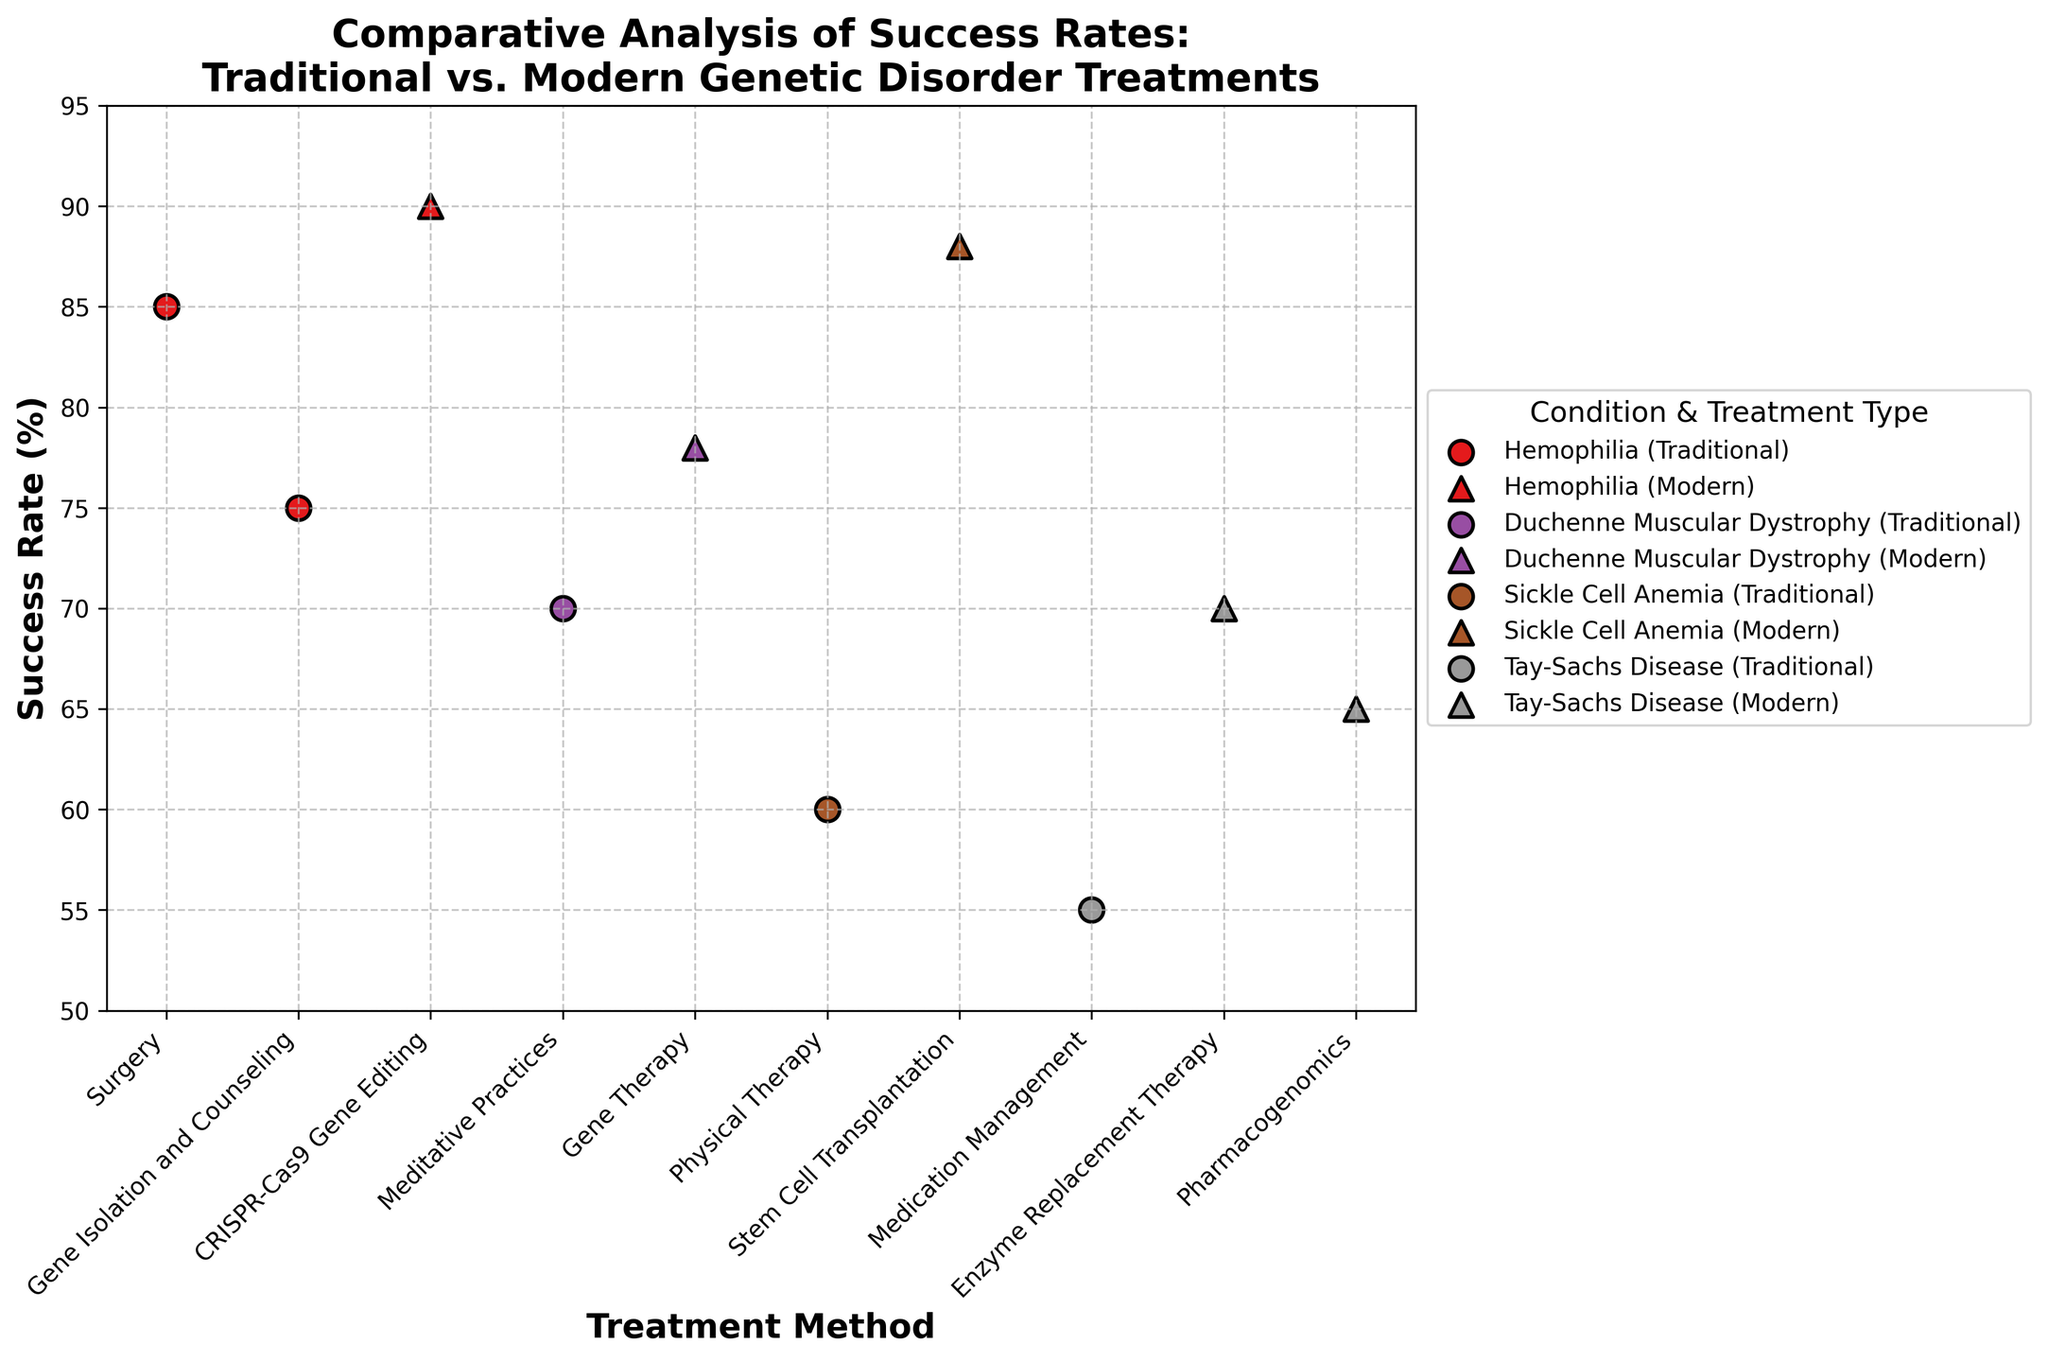Which treatment method has the highest success rate for Tay-Sachs Disease? The treatment methods for Tay-Sachs Disease are "Medication Management," "Enzyme Replacement Therapy," and "Pharmacogenomics." By looking at the success rates, "Enzyme Replacement Therapy" has the highest success rate at 70%.
Answer: Enzyme Replacement Therapy How do the success rates of CRISPR-Cas9 Gene Editing and Surgery compare for Hemophilia? The success rates for these treatments of Hemophilia are: CRISPR-Cas9 Gene Editing (90%) and Surgery (85%). CRISPR-Cas9 Gene Editing has a higher success rate than Surgery.
Answer: CRISPR-Cas9 Gene Editing is higher What is the average success rate for traditional treatments across all conditions? The traditional treatments and their success rates are: Surgery (85%), Meditative Practices (70%), Physical Therapy (60%), Medication Management (55%), and Gene Isolation and Counseling (75%). The average is calculated as: (85 + 70 + 60 + 55 + 75) /5 = 69%.
Answer: 69% Which condition has the largest difference in success rates between traditional and modern treatments? The differences in success rates for each condition are: Hemophilia (90-85=5), Duchenne Muscular Dystrophy (78-70=8), Sickle Cell Anemia (88-60=28), and Tay-Sachs Disease (70-55=15). Sickle Cell Anemia has the largest difference of 28%.
Answer: Sickle Cell Anemia Is there a condition for which traditional treatments have a higher success rate than modern treatments? For all conditions (Hemophilia, Duchenne Muscular Dystrophy, Sickle Cell Anemia, Tay-Sachs Disease), modern treatments have higher or equal success rates compared to traditional treatments.
Answer: No What is the range of success rates for all modern treatments? The success rates for modern treatments are: CRISPR-Cas9 Gene Editing (90%), Gene Therapy (78%), Stem Cell Transplantation (88%), Enzyme Replacement Therapy (70%), Pharmacogenomics (65%). The range is calculated as: 90% - 65% = 25%.
Answer: 25% Which modern treatment has the lowest success rate, and for which condition is it used? Among modern treatments, "Pharmacogenomics" has the lowest success rate at 65%, and it is used for Tay-Sachs Disease.
Answer: Pharmacogenomics for Tay-Sachs Disease What are the two treatment methods with the closest success rates for Sickle Cell Anemia? For Sickle Cell Anemia, the success rates are: Physical Therapy (60%) and Stem Cell Transplantation (88%). The difference is calculated as: 88 - 60 = 28% difference. They are far apart, so there's only one treatment method for this condition per treatment type.
Answer: Not applicable 